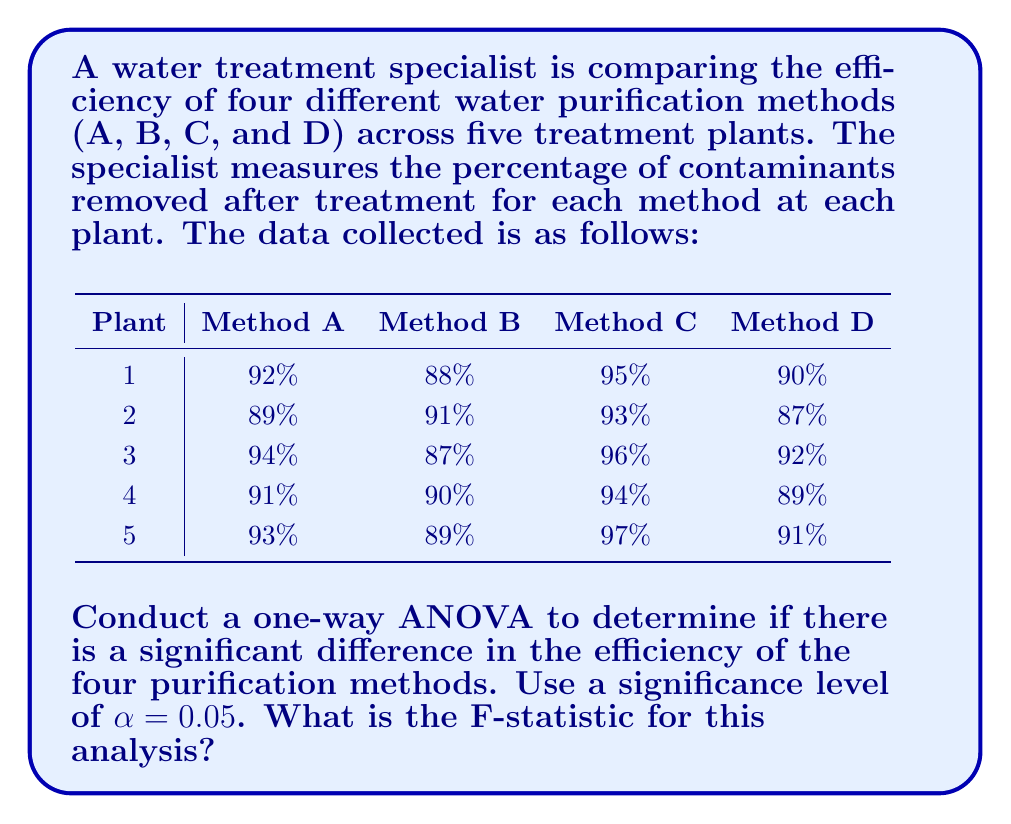Teach me how to tackle this problem. To conduct a one-way ANOVA, we need to follow these steps:

1. Calculate the mean for each group (method) and the grand mean.
2. Calculate the Sum of Squares Between (SSB) and Sum of Squares Within (SSW).
3. Calculate the degrees of freedom for between groups (dfB) and within groups (dfW).
4. Calculate the Mean Square Between (MSB) and Mean Square Within (MSW).
5. Calculate the F-statistic.

Step 1: Calculate means
Method A mean: $\bar{X}_A = \frac{92 + 89 + 94 + 91 + 93}{5} = 91.8\%$
Method B mean: $\bar{X}_B = \frac{88 + 91 + 87 + 90 + 89}{5} = 89.0\%$
Method C mean: $\bar{X}_C = \frac{95 + 93 + 96 + 94 + 97}{5} = 95.0\%$
Method D mean: $\bar{X}_D = \frac{90 + 87 + 92 + 89 + 91}{5} = 89.8\%$

Grand mean: $\bar{X} = \frac{91.8 + 89.0 + 95.0 + 89.8}{4} = 91.4\%$

Step 2: Calculate SSB and SSW
SSB = $\sum_{i=1}^k n_i(\bar{X}_i - \bar{X})^2$
    = $5[(91.8 - 91.4)^2 + (89.0 - 91.4)^2 + (95.0 - 91.4)^2 + (89.8 - 91.4)^2]$
    = $5[0.16 + 5.76 + 12.96 + 2.56]$
    = $5(21.44) = 107.2$

SSW = $\sum_{i=1}^k \sum_{j=1}^{n_i} (X_{ij} - \bar{X}_i)^2$
    = $(92-91.8)^2 + (89-91.8)^2 + ... + (91-89.8)^2$
    = $62.8$

Step 3: Calculate degrees of freedom
dfB = $k - 1 = 4 - 1 = 3$
dfW = $N - k = 20 - 4 = 16$

Step 4: Calculate MSB and MSW
MSB = $\frac{SSB}{dfB} = \frac{107.2}{3} = 35.73$
MSW = $\frac{SSW}{dfW} = \frac{62.8}{16} = 3.93$

Step 5: Calculate F-statistic
$$F = \frac{MSB}{MSW} = \frac{35.73}{3.93} = 9.09$$
Answer: The F-statistic for this one-way ANOVA is 9.09. 